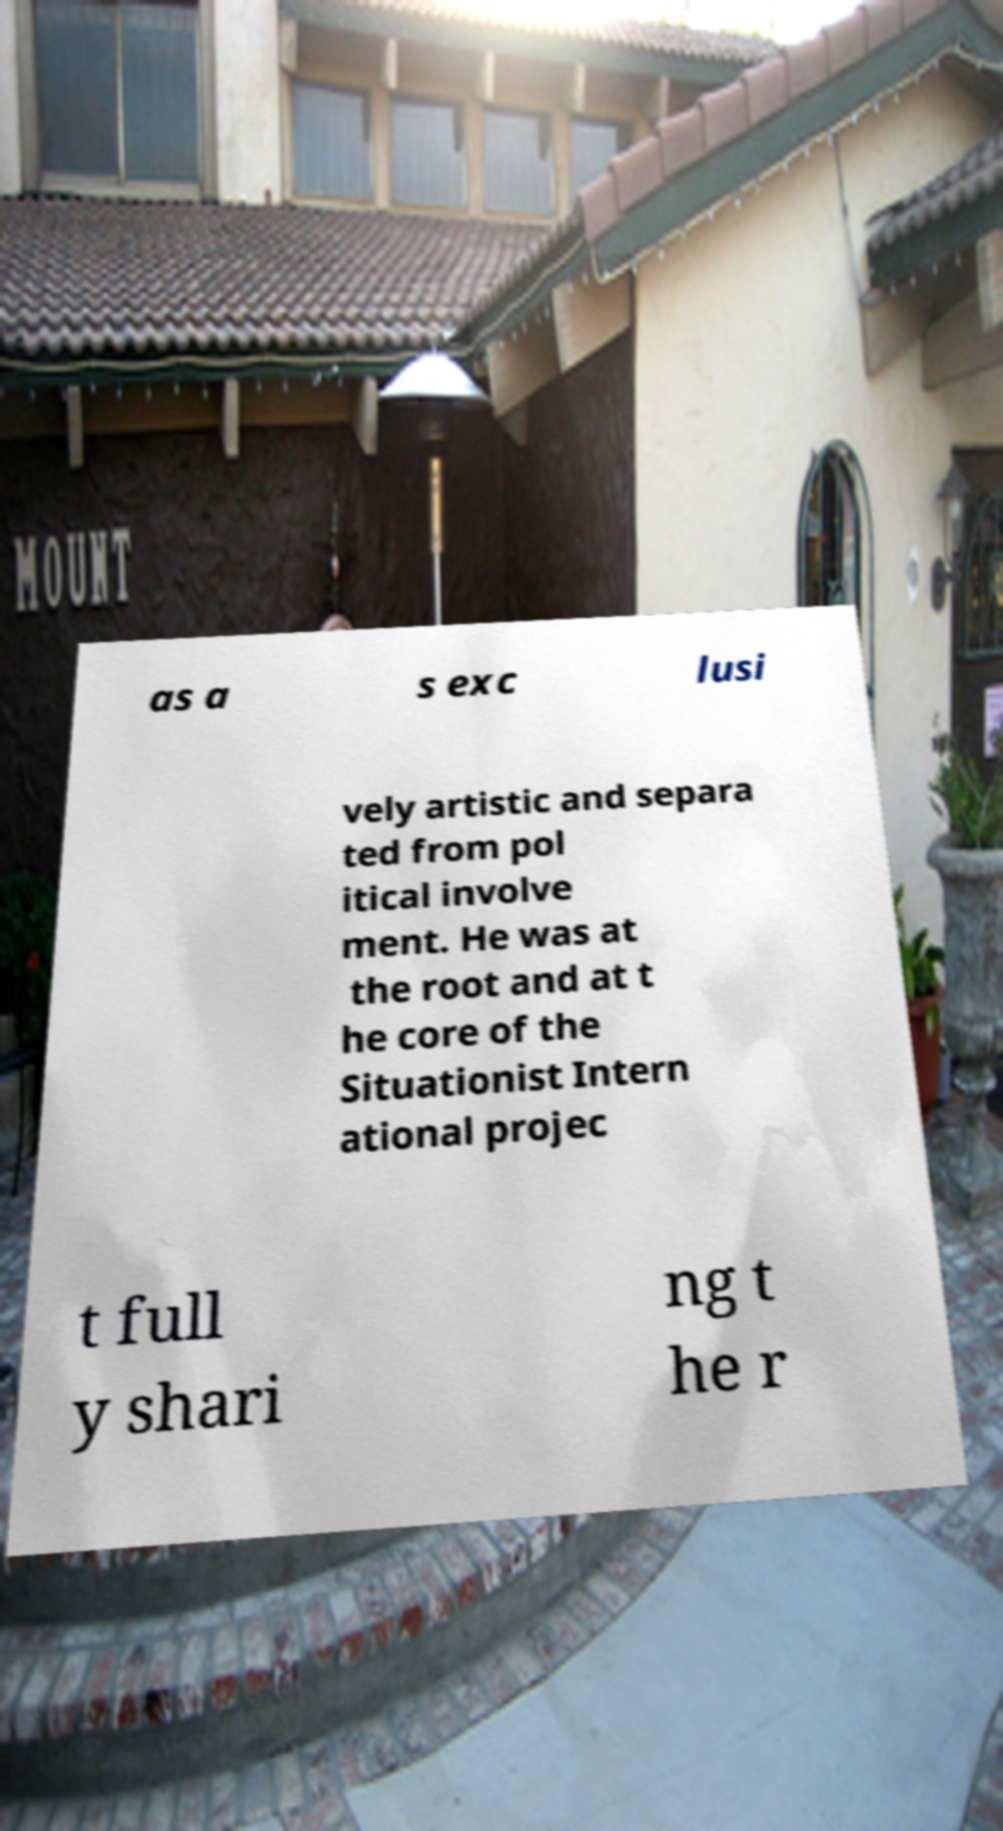I need the written content from this picture converted into text. Can you do that? as a s exc lusi vely artistic and separa ted from pol itical involve ment. He was at the root and at t he core of the Situationist Intern ational projec t full y shari ng t he r 